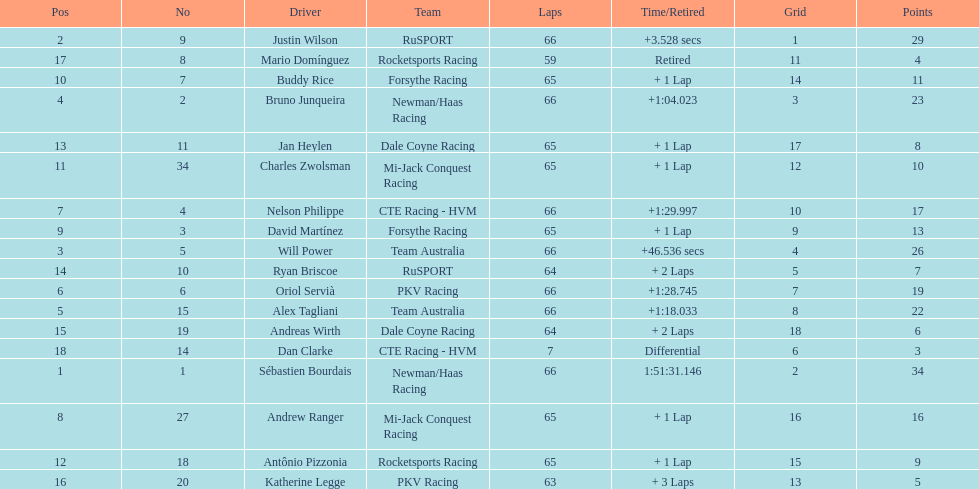Which country had more drivers representing them, the us or germany? Tie. 